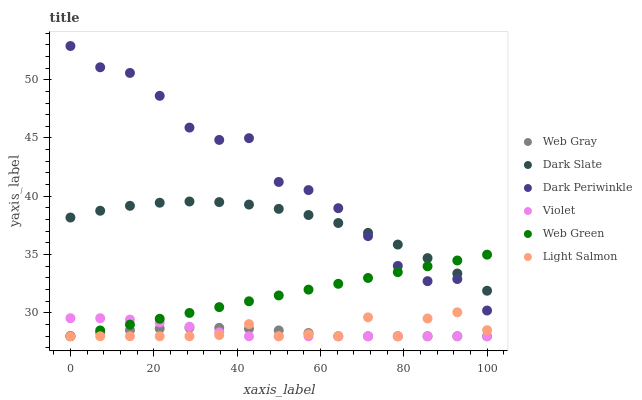Does Web Gray have the minimum area under the curve?
Answer yes or no. Yes. Does Dark Periwinkle have the maximum area under the curve?
Answer yes or no. Yes. Does Web Green have the minimum area under the curve?
Answer yes or no. No. Does Web Green have the maximum area under the curve?
Answer yes or no. No. Is Web Green the smoothest?
Answer yes or no. Yes. Is Dark Periwinkle the roughest?
Answer yes or no. Yes. Is Web Gray the smoothest?
Answer yes or no. No. Is Web Gray the roughest?
Answer yes or no. No. Does Light Salmon have the lowest value?
Answer yes or no. Yes. Does Dark Slate have the lowest value?
Answer yes or no. No. Does Dark Periwinkle have the highest value?
Answer yes or no. Yes. Does Web Green have the highest value?
Answer yes or no. No. Is Light Salmon less than Dark Periwinkle?
Answer yes or no. Yes. Is Dark Periwinkle greater than Web Gray?
Answer yes or no. Yes. Does Web Green intersect Violet?
Answer yes or no. Yes. Is Web Green less than Violet?
Answer yes or no. No. Is Web Green greater than Violet?
Answer yes or no. No. Does Light Salmon intersect Dark Periwinkle?
Answer yes or no. No. 